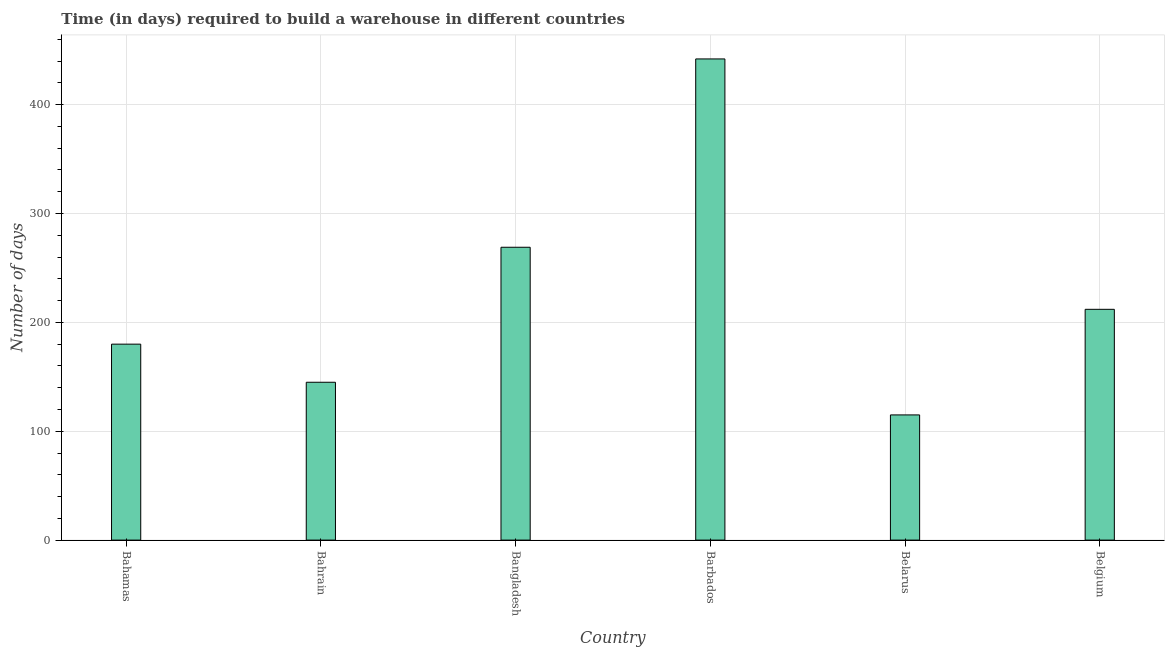Does the graph contain any zero values?
Ensure brevity in your answer.  No. Does the graph contain grids?
Provide a short and direct response. Yes. What is the title of the graph?
Offer a very short reply. Time (in days) required to build a warehouse in different countries. What is the label or title of the X-axis?
Your answer should be compact. Country. What is the label or title of the Y-axis?
Provide a succinct answer. Number of days. What is the time required to build a warehouse in Barbados?
Your answer should be compact. 442. Across all countries, what is the maximum time required to build a warehouse?
Give a very brief answer. 442. Across all countries, what is the minimum time required to build a warehouse?
Your answer should be very brief. 115. In which country was the time required to build a warehouse maximum?
Make the answer very short. Barbados. In which country was the time required to build a warehouse minimum?
Make the answer very short. Belarus. What is the sum of the time required to build a warehouse?
Offer a very short reply. 1363. What is the difference between the time required to build a warehouse in Bahamas and Belgium?
Ensure brevity in your answer.  -32. What is the average time required to build a warehouse per country?
Make the answer very short. 227.17. What is the median time required to build a warehouse?
Provide a succinct answer. 196. In how many countries, is the time required to build a warehouse greater than 320 days?
Give a very brief answer. 1. What is the ratio of the time required to build a warehouse in Bahamas to that in Barbados?
Your answer should be compact. 0.41. Is the time required to build a warehouse in Bahrain less than that in Belgium?
Provide a succinct answer. Yes. Is the difference between the time required to build a warehouse in Barbados and Belgium greater than the difference between any two countries?
Provide a succinct answer. No. What is the difference between the highest and the second highest time required to build a warehouse?
Give a very brief answer. 173. What is the difference between the highest and the lowest time required to build a warehouse?
Offer a very short reply. 327. In how many countries, is the time required to build a warehouse greater than the average time required to build a warehouse taken over all countries?
Provide a succinct answer. 2. Are the values on the major ticks of Y-axis written in scientific E-notation?
Offer a very short reply. No. What is the Number of days of Bahamas?
Give a very brief answer. 180. What is the Number of days in Bahrain?
Your answer should be very brief. 145. What is the Number of days of Bangladesh?
Your answer should be very brief. 269. What is the Number of days in Barbados?
Provide a short and direct response. 442. What is the Number of days in Belarus?
Make the answer very short. 115. What is the Number of days of Belgium?
Your response must be concise. 212. What is the difference between the Number of days in Bahamas and Bahrain?
Make the answer very short. 35. What is the difference between the Number of days in Bahamas and Bangladesh?
Provide a short and direct response. -89. What is the difference between the Number of days in Bahamas and Barbados?
Your answer should be very brief. -262. What is the difference between the Number of days in Bahamas and Belarus?
Your answer should be very brief. 65. What is the difference between the Number of days in Bahamas and Belgium?
Offer a terse response. -32. What is the difference between the Number of days in Bahrain and Bangladesh?
Provide a succinct answer. -124. What is the difference between the Number of days in Bahrain and Barbados?
Provide a succinct answer. -297. What is the difference between the Number of days in Bahrain and Belgium?
Give a very brief answer. -67. What is the difference between the Number of days in Bangladesh and Barbados?
Provide a succinct answer. -173. What is the difference between the Number of days in Bangladesh and Belarus?
Give a very brief answer. 154. What is the difference between the Number of days in Bangladesh and Belgium?
Ensure brevity in your answer.  57. What is the difference between the Number of days in Barbados and Belarus?
Your answer should be very brief. 327. What is the difference between the Number of days in Barbados and Belgium?
Make the answer very short. 230. What is the difference between the Number of days in Belarus and Belgium?
Give a very brief answer. -97. What is the ratio of the Number of days in Bahamas to that in Bahrain?
Provide a short and direct response. 1.24. What is the ratio of the Number of days in Bahamas to that in Bangladesh?
Keep it short and to the point. 0.67. What is the ratio of the Number of days in Bahamas to that in Barbados?
Offer a very short reply. 0.41. What is the ratio of the Number of days in Bahamas to that in Belarus?
Ensure brevity in your answer.  1.56. What is the ratio of the Number of days in Bahamas to that in Belgium?
Offer a terse response. 0.85. What is the ratio of the Number of days in Bahrain to that in Bangladesh?
Your answer should be very brief. 0.54. What is the ratio of the Number of days in Bahrain to that in Barbados?
Your answer should be very brief. 0.33. What is the ratio of the Number of days in Bahrain to that in Belarus?
Your response must be concise. 1.26. What is the ratio of the Number of days in Bahrain to that in Belgium?
Offer a terse response. 0.68. What is the ratio of the Number of days in Bangladesh to that in Barbados?
Make the answer very short. 0.61. What is the ratio of the Number of days in Bangladesh to that in Belarus?
Provide a short and direct response. 2.34. What is the ratio of the Number of days in Bangladesh to that in Belgium?
Give a very brief answer. 1.27. What is the ratio of the Number of days in Barbados to that in Belarus?
Your answer should be compact. 3.84. What is the ratio of the Number of days in Barbados to that in Belgium?
Provide a succinct answer. 2.08. What is the ratio of the Number of days in Belarus to that in Belgium?
Keep it short and to the point. 0.54. 